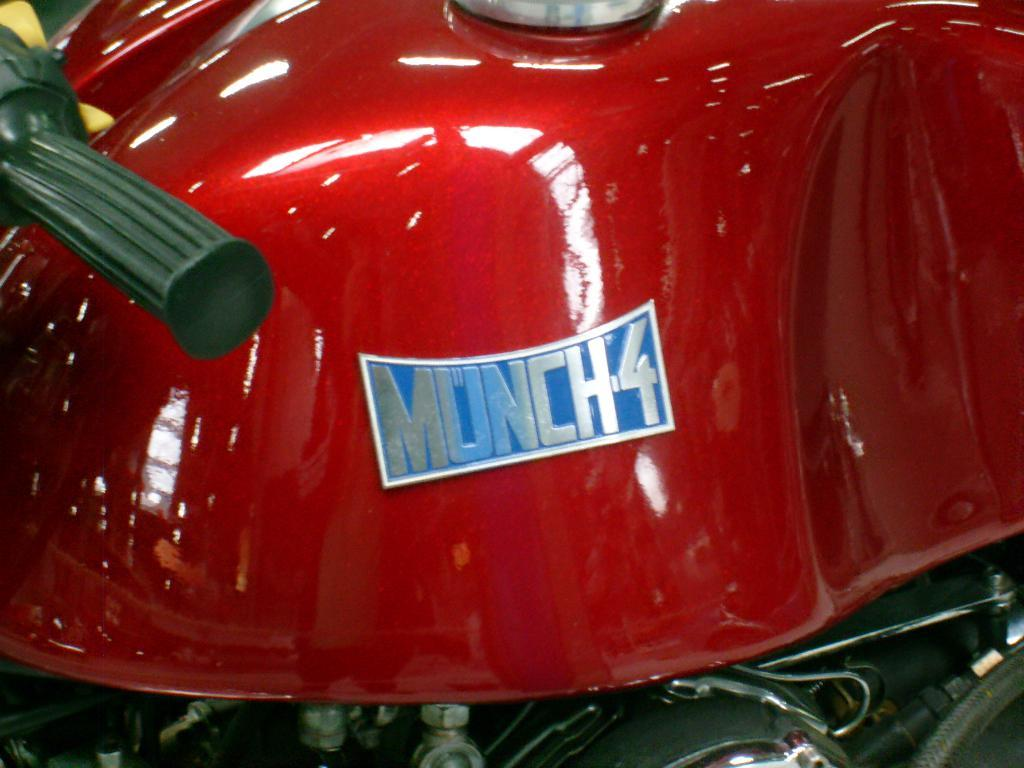What is the main subject of the image? The main subject of the image is a vehicle. Can you describe the color of the vehicle? The vehicle is red in color. Is there anything attached to the vehicle? Yes, there is a board attached to the vehicle. What is written on the board? The board has the text "munch4" written on it. How does the vehicle help with arithmetic in the image? The image does not show the vehicle helping with arithmetic, as it only displays the vehicle's color and the text on the board. 